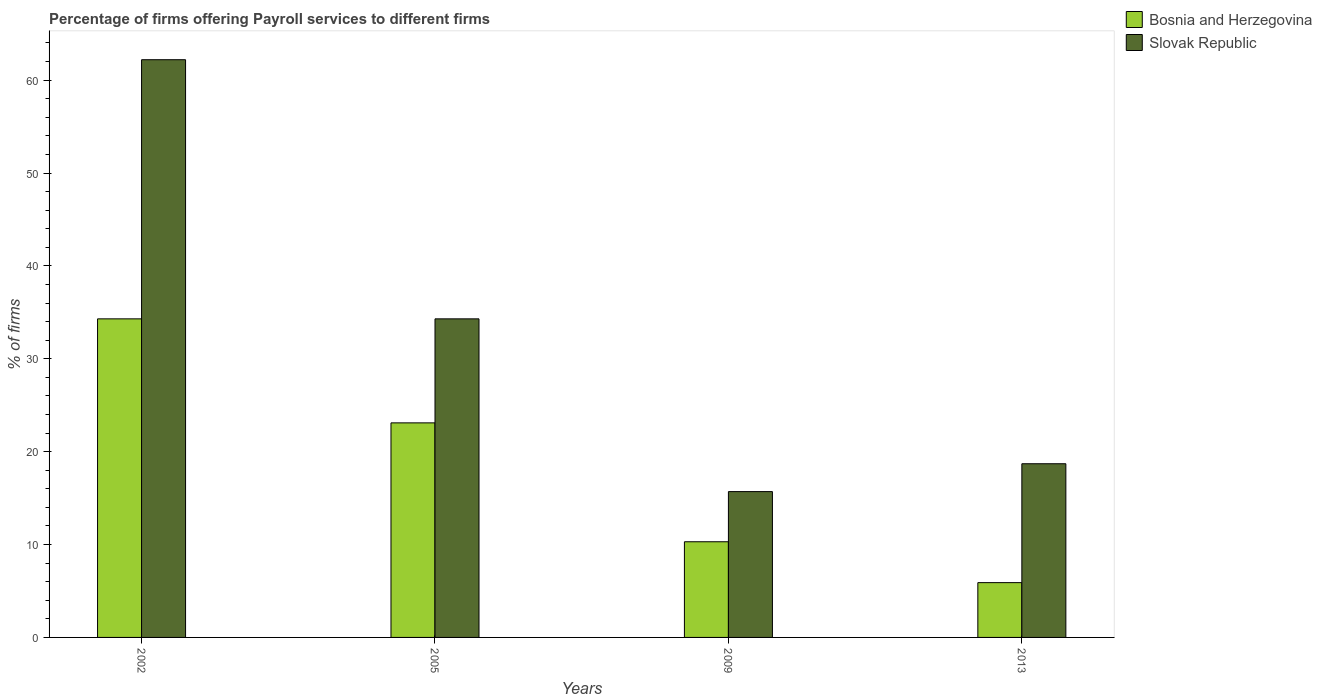How many groups of bars are there?
Offer a terse response. 4. How many bars are there on the 1st tick from the left?
Keep it short and to the point. 2. What is the label of the 2nd group of bars from the left?
Offer a terse response. 2005. In how many cases, is the number of bars for a given year not equal to the number of legend labels?
Your answer should be very brief. 0. Across all years, what is the maximum percentage of firms offering payroll services in Slovak Republic?
Give a very brief answer. 62.2. In which year was the percentage of firms offering payroll services in Slovak Republic maximum?
Your response must be concise. 2002. In which year was the percentage of firms offering payroll services in Slovak Republic minimum?
Your answer should be very brief. 2009. What is the total percentage of firms offering payroll services in Slovak Republic in the graph?
Make the answer very short. 130.9. What is the difference between the percentage of firms offering payroll services in Slovak Republic in 2002 and that in 2013?
Offer a very short reply. 43.5. What is the difference between the percentage of firms offering payroll services in Slovak Republic in 2009 and the percentage of firms offering payroll services in Bosnia and Herzegovina in 2002?
Offer a very short reply. -18.6. What is the average percentage of firms offering payroll services in Slovak Republic per year?
Provide a succinct answer. 32.73. In the year 2013, what is the difference between the percentage of firms offering payroll services in Bosnia and Herzegovina and percentage of firms offering payroll services in Slovak Republic?
Offer a terse response. -12.8. What is the ratio of the percentage of firms offering payroll services in Slovak Republic in 2002 to that in 2013?
Ensure brevity in your answer.  3.33. Is the percentage of firms offering payroll services in Bosnia and Herzegovina in 2005 less than that in 2009?
Offer a very short reply. No. What is the difference between the highest and the second highest percentage of firms offering payroll services in Slovak Republic?
Provide a succinct answer. 27.9. What is the difference between the highest and the lowest percentage of firms offering payroll services in Bosnia and Herzegovina?
Offer a terse response. 28.4. In how many years, is the percentage of firms offering payroll services in Slovak Republic greater than the average percentage of firms offering payroll services in Slovak Republic taken over all years?
Offer a terse response. 2. What does the 2nd bar from the left in 2002 represents?
Ensure brevity in your answer.  Slovak Republic. What does the 2nd bar from the right in 2005 represents?
Provide a short and direct response. Bosnia and Herzegovina. How many bars are there?
Your response must be concise. 8. Are all the bars in the graph horizontal?
Your answer should be compact. No. How many years are there in the graph?
Offer a terse response. 4. What is the difference between two consecutive major ticks on the Y-axis?
Provide a succinct answer. 10. Does the graph contain any zero values?
Ensure brevity in your answer.  No. Does the graph contain grids?
Your answer should be compact. No. What is the title of the graph?
Your answer should be very brief. Percentage of firms offering Payroll services to different firms. Does "Least developed countries" appear as one of the legend labels in the graph?
Offer a very short reply. No. What is the label or title of the Y-axis?
Offer a very short reply. % of firms. What is the % of firms in Bosnia and Herzegovina in 2002?
Offer a terse response. 34.3. What is the % of firms of Slovak Republic in 2002?
Offer a terse response. 62.2. What is the % of firms of Bosnia and Herzegovina in 2005?
Your answer should be very brief. 23.1. What is the % of firms in Slovak Republic in 2005?
Keep it short and to the point. 34.3. What is the % of firms in Bosnia and Herzegovina in 2013?
Keep it short and to the point. 5.9. What is the % of firms in Slovak Republic in 2013?
Offer a terse response. 18.7. Across all years, what is the maximum % of firms in Bosnia and Herzegovina?
Ensure brevity in your answer.  34.3. Across all years, what is the maximum % of firms in Slovak Republic?
Make the answer very short. 62.2. Across all years, what is the minimum % of firms of Bosnia and Herzegovina?
Offer a very short reply. 5.9. What is the total % of firms in Bosnia and Herzegovina in the graph?
Your answer should be very brief. 73.6. What is the total % of firms in Slovak Republic in the graph?
Your response must be concise. 130.9. What is the difference between the % of firms in Slovak Republic in 2002 and that in 2005?
Make the answer very short. 27.9. What is the difference between the % of firms in Slovak Republic in 2002 and that in 2009?
Provide a short and direct response. 46.5. What is the difference between the % of firms of Bosnia and Herzegovina in 2002 and that in 2013?
Your answer should be compact. 28.4. What is the difference between the % of firms of Slovak Republic in 2002 and that in 2013?
Give a very brief answer. 43.5. What is the difference between the % of firms of Bosnia and Herzegovina in 2005 and that in 2013?
Your response must be concise. 17.2. What is the difference between the % of firms in Bosnia and Herzegovina in 2009 and that in 2013?
Provide a succinct answer. 4.4. What is the difference between the % of firms of Slovak Republic in 2009 and that in 2013?
Offer a very short reply. -3. What is the difference between the % of firms in Bosnia and Herzegovina in 2002 and the % of firms in Slovak Republic in 2005?
Ensure brevity in your answer.  0. What is the difference between the % of firms in Bosnia and Herzegovina in 2002 and the % of firms in Slovak Republic in 2009?
Keep it short and to the point. 18.6. What is the difference between the % of firms of Bosnia and Herzegovina in 2009 and the % of firms of Slovak Republic in 2013?
Make the answer very short. -8.4. What is the average % of firms in Bosnia and Herzegovina per year?
Your response must be concise. 18.4. What is the average % of firms in Slovak Republic per year?
Offer a very short reply. 32.73. In the year 2002, what is the difference between the % of firms in Bosnia and Herzegovina and % of firms in Slovak Republic?
Your response must be concise. -27.9. In the year 2005, what is the difference between the % of firms of Bosnia and Herzegovina and % of firms of Slovak Republic?
Offer a very short reply. -11.2. In the year 2009, what is the difference between the % of firms of Bosnia and Herzegovina and % of firms of Slovak Republic?
Offer a terse response. -5.4. What is the ratio of the % of firms in Bosnia and Herzegovina in 2002 to that in 2005?
Make the answer very short. 1.48. What is the ratio of the % of firms in Slovak Republic in 2002 to that in 2005?
Offer a very short reply. 1.81. What is the ratio of the % of firms of Bosnia and Herzegovina in 2002 to that in 2009?
Make the answer very short. 3.33. What is the ratio of the % of firms in Slovak Republic in 2002 to that in 2009?
Keep it short and to the point. 3.96. What is the ratio of the % of firms in Bosnia and Herzegovina in 2002 to that in 2013?
Give a very brief answer. 5.81. What is the ratio of the % of firms in Slovak Republic in 2002 to that in 2013?
Your answer should be compact. 3.33. What is the ratio of the % of firms of Bosnia and Herzegovina in 2005 to that in 2009?
Your answer should be compact. 2.24. What is the ratio of the % of firms of Slovak Republic in 2005 to that in 2009?
Offer a very short reply. 2.18. What is the ratio of the % of firms of Bosnia and Herzegovina in 2005 to that in 2013?
Provide a succinct answer. 3.92. What is the ratio of the % of firms in Slovak Republic in 2005 to that in 2013?
Provide a succinct answer. 1.83. What is the ratio of the % of firms of Bosnia and Herzegovina in 2009 to that in 2013?
Provide a short and direct response. 1.75. What is the ratio of the % of firms of Slovak Republic in 2009 to that in 2013?
Provide a short and direct response. 0.84. What is the difference between the highest and the second highest % of firms of Bosnia and Herzegovina?
Keep it short and to the point. 11.2. What is the difference between the highest and the second highest % of firms of Slovak Republic?
Your response must be concise. 27.9. What is the difference between the highest and the lowest % of firms in Bosnia and Herzegovina?
Keep it short and to the point. 28.4. What is the difference between the highest and the lowest % of firms in Slovak Republic?
Provide a succinct answer. 46.5. 